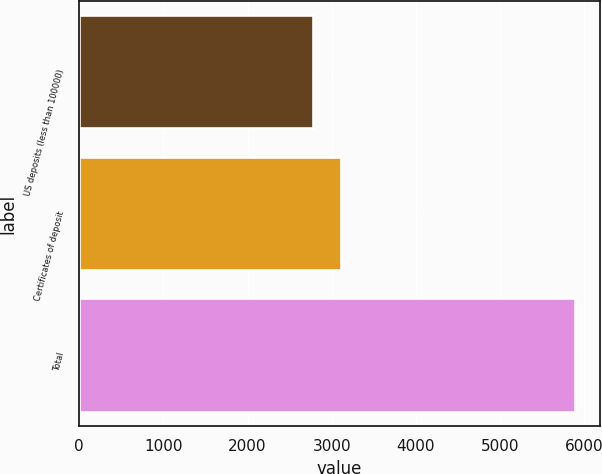<chart> <loc_0><loc_0><loc_500><loc_500><bar_chart><fcel>US deposits (less than 100000)<fcel>Certificates of deposit<fcel>Total<nl><fcel>2779<fcel>3108<fcel>5887<nl></chart> 